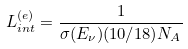<formula> <loc_0><loc_0><loc_500><loc_500>L _ { i n t } ^ { ( e ) } = \frac { 1 } { \sigma ( E _ { \nu } ) ( 1 0 / 1 8 ) N _ { A } } \,</formula> 